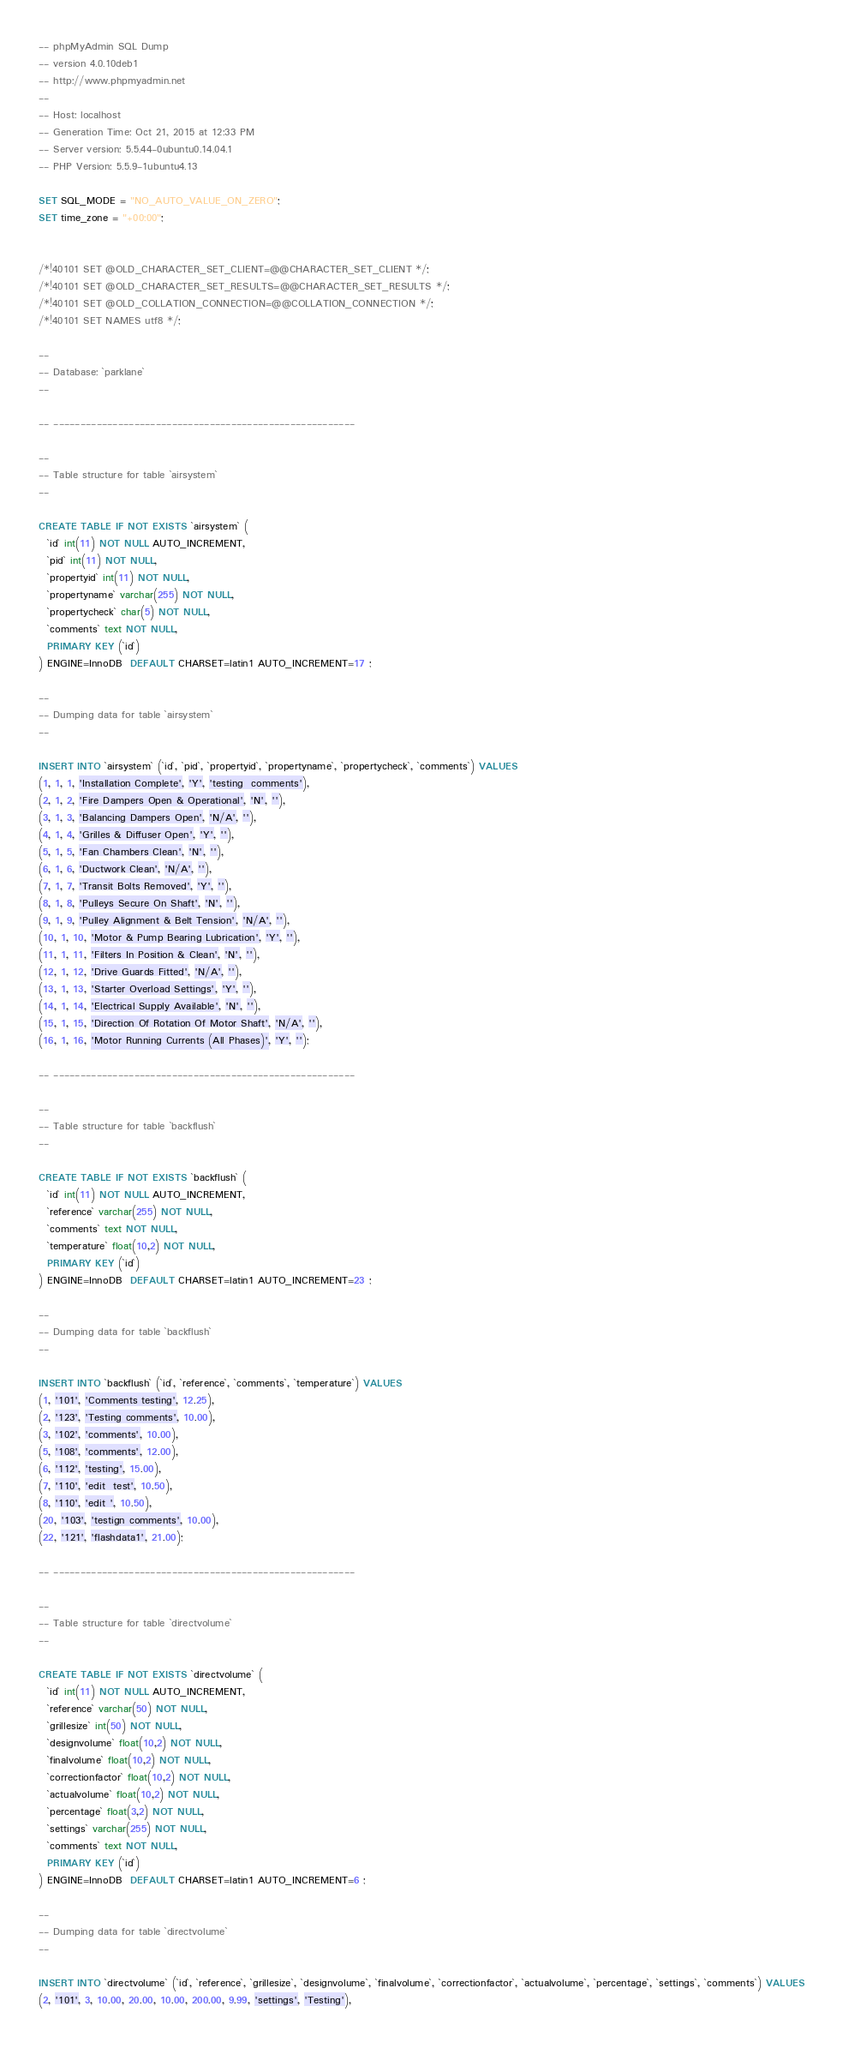Convert code to text. <code><loc_0><loc_0><loc_500><loc_500><_SQL_>-- phpMyAdmin SQL Dump
-- version 4.0.10deb1
-- http://www.phpmyadmin.net
--
-- Host: localhost
-- Generation Time: Oct 21, 2015 at 12:33 PM
-- Server version: 5.5.44-0ubuntu0.14.04.1
-- PHP Version: 5.5.9-1ubuntu4.13

SET SQL_MODE = "NO_AUTO_VALUE_ON_ZERO";
SET time_zone = "+00:00";


/*!40101 SET @OLD_CHARACTER_SET_CLIENT=@@CHARACTER_SET_CLIENT */;
/*!40101 SET @OLD_CHARACTER_SET_RESULTS=@@CHARACTER_SET_RESULTS */;
/*!40101 SET @OLD_COLLATION_CONNECTION=@@COLLATION_CONNECTION */;
/*!40101 SET NAMES utf8 */;

--
-- Database: `parklane`
--

-- --------------------------------------------------------

--
-- Table structure for table `airsystem`
--

CREATE TABLE IF NOT EXISTS `airsystem` (
  `id` int(11) NOT NULL AUTO_INCREMENT,
  `pid` int(11) NOT NULL,
  `propertyid` int(11) NOT NULL,
  `propertyname` varchar(255) NOT NULL,
  `propertycheck` char(5) NOT NULL,
  `comments` text NOT NULL,
  PRIMARY KEY (`id`)
) ENGINE=InnoDB  DEFAULT CHARSET=latin1 AUTO_INCREMENT=17 ;

--
-- Dumping data for table `airsystem`
--

INSERT INTO `airsystem` (`id`, `pid`, `propertyid`, `propertyname`, `propertycheck`, `comments`) VALUES
(1, 1, 1, 'Installation Complete', 'Y', 'testing  comments'),
(2, 1, 2, 'Fire Dampers Open & Operational', 'N', ''),
(3, 1, 3, 'Balancing Dampers Open', 'N/A', ''),
(4, 1, 4, 'Grilles & Diffuser Open', 'Y', ''),
(5, 1, 5, 'Fan Chambers Clean', 'N', ''),
(6, 1, 6, 'Ductwork Clean', 'N/A', ''),
(7, 1, 7, 'Transit Bolts Removed', 'Y', ''),
(8, 1, 8, 'Pulleys Secure On Shaft', 'N', ''),
(9, 1, 9, 'Pulley Alignment & Belt Tension', 'N/A', ''),
(10, 1, 10, 'Motor & Pump Bearing Lubrication', 'Y', ''),
(11, 1, 11, 'Filters In Position & Clean', 'N', ''),
(12, 1, 12, 'Drive Guards Fitted', 'N/A', ''),
(13, 1, 13, 'Starter Overload Settings', 'Y', ''),
(14, 1, 14, 'Electrical Supply Available', 'N', ''),
(15, 1, 15, 'Direction Of Rotation Of Motor Shaft', 'N/A', ''),
(16, 1, 16, 'Motor Running Currents (All Phases)', 'Y', '');

-- --------------------------------------------------------

--
-- Table structure for table `backflush`
--

CREATE TABLE IF NOT EXISTS `backflush` (
  `id` int(11) NOT NULL AUTO_INCREMENT,
  `reference` varchar(255) NOT NULL,
  `comments` text NOT NULL,
  `temperature` float(10,2) NOT NULL,
  PRIMARY KEY (`id`)
) ENGINE=InnoDB  DEFAULT CHARSET=latin1 AUTO_INCREMENT=23 ;

--
-- Dumping data for table `backflush`
--

INSERT INTO `backflush` (`id`, `reference`, `comments`, `temperature`) VALUES
(1, '101', 'Comments testing', 12.25),
(2, '123', 'Testing comments', 10.00),
(3, '102', 'comments', 10.00),
(5, '108', 'comments', 12.00),
(6, '112', 'testing', 15.00),
(7, '110', 'edit  test', 10.50),
(8, '110', 'edit ', 10.50),
(20, '103', 'testign comments', 10.00),
(22, '121', 'flashdata1', 21.00);

-- --------------------------------------------------------

--
-- Table structure for table `directvolume`
--

CREATE TABLE IF NOT EXISTS `directvolume` (
  `id` int(11) NOT NULL AUTO_INCREMENT,
  `reference` varchar(50) NOT NULL,
  `grillesize` int(50) NOT NULL,
  `designvolume` float(10,2) NOT NULL,
  `finalvolume` float(10,2) NOT NULL,
  `correctionfactor` float(10,2) NOT NULL,
  `actualvolume` float(10,2) NOT NULL,
  `percentage` float(3,2) NOT NULL,
  `settings` varchar(255) NOT NULL,
  `comments` text NOT NULL,
  PRIMARY KEY (`id`)
) ENGINE=InnoDB  DEFAULT CHARSET=latin1 AUTO_INCREMENT=6 ;

--
-- Dumping data for table `directvolume`
--

INSERT INTO `directvolume` (`id`, `reference`, `grillesize`, `designvolume`, `finalvolume`, `correctionfactor`, `actualvolume`, `percentage`, `settings`, `comments`) VALUES
(2, '101', 3, 10.00, 20.00, 10.00, 200.00, 9.99, 'settings', 'Testing'),</code> 